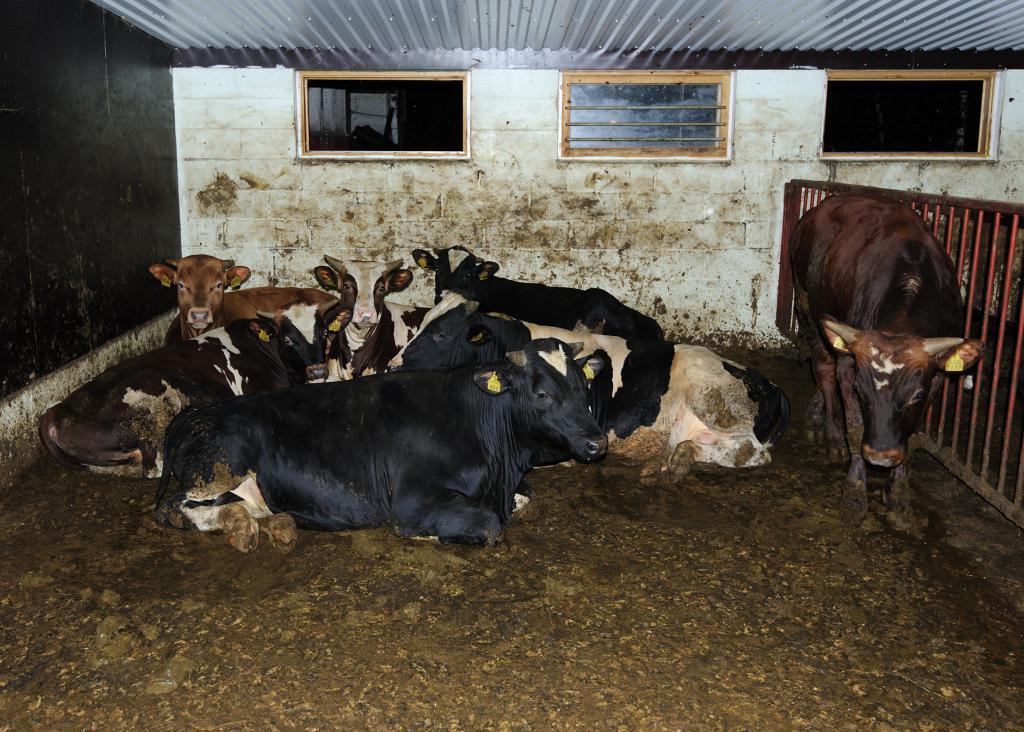How would you summarize this image in a sentence or two? In this picture we can see a few animals sitting on the ground. We can see an animal standing on the ground visible on the right side. There is a fence visible on the right side. We can see a steel plated roofing sheet on top of the picture. A wall is visible in the background. 